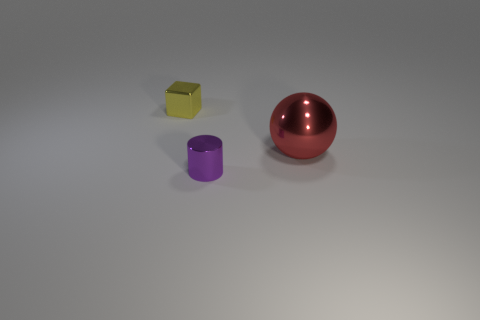The tiny thing in front of the small yellow metallic object has what shape?
Offer a terse response. Cylinder. Is there any other thing that is the same material as the cube?
Give a very brief answer. Yes. Are there more small purple metal cylinders that are to the right of the big red metal sphere than metallic cubes?
Provide a succinct answer. No. There is a metallic object that is behind the thing that is on the right side of the tiny cylinder; what number of big balls are right of it?
Offer a very short reply. 1. Do the object behind the red shiny thing and the thing that is on the right side of the purple metallic object have the same size?
Give a very brief answer. No. The object right of the small shiny object that is in front of the red metallic ball is made of what material?
Give a very brief answer. Metal. What number of things are tiny things that are in front of the red ball or tiny gray metallic objects?
Your response must be concise. 1. Is the number of red spheres that are behind the yellow shiny block the same as the number of tiny metal blocks right of the metallic sphere?
Ensure brevity in your answer.  Yes. How big is the metallic object that is to the left of the large red metal thing and behind the purple metallic object?
Keep it short and to the point. Small. The purple thing that is the same material as the tiny block is what shape?
Your answer should be very brief. Cylinder. 